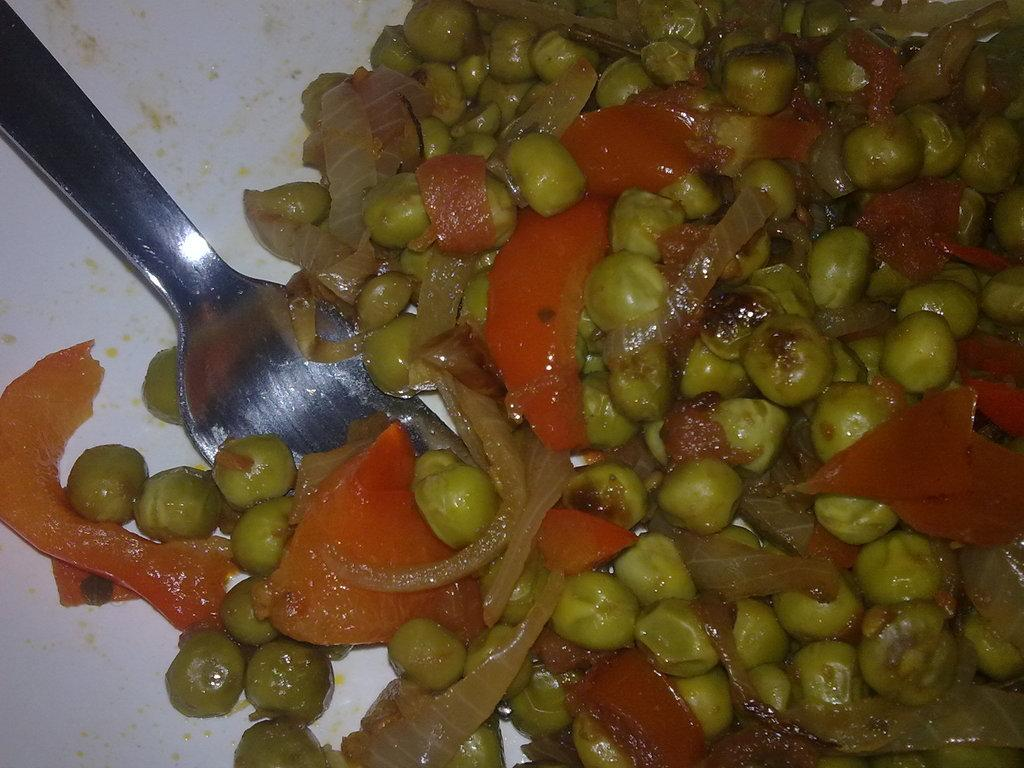What types of items can be seen in the image? There are food items in the image. What utensil is present in the image? There is a spoon in the image. Can you describe the object that contains the spoon? The spoon is in a white-colored object. How many cacti are visible in the image? There are no cacti present in the image. What type of oil is being used to cook the food in the image? There is no oil visible in the image, and the food items do not appear to be cooked. 